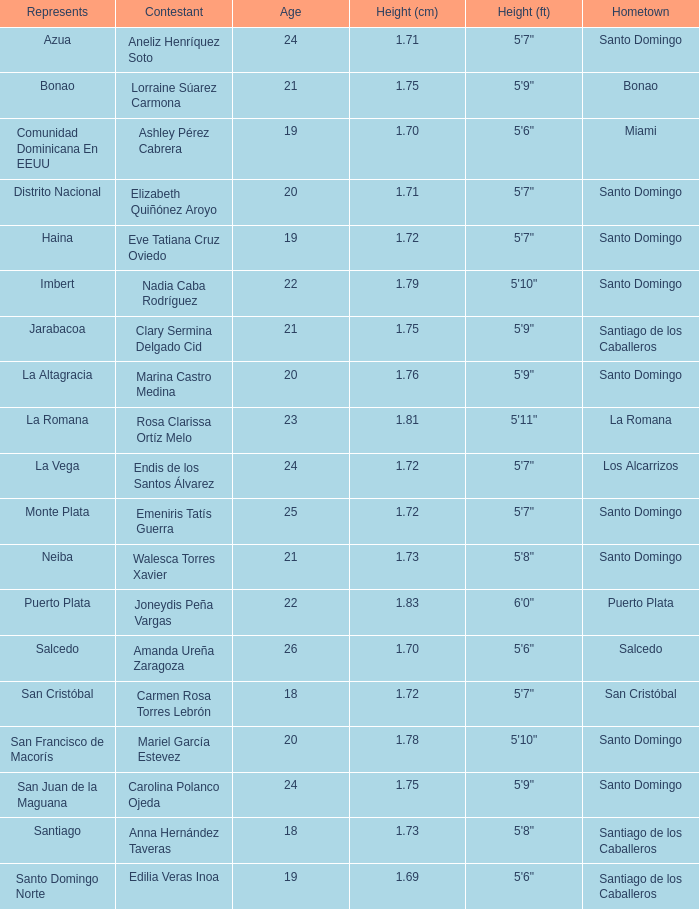Identify the representatives for los alcarrizos. La Vega. 